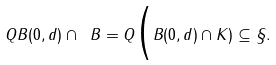Convert formula to latex. <formula><loc_0><loc_0><loc_500><loc_500>Q B ( 0 , d ) \cap \ B = Q \Big ( B ( 0 , d ) \cap K ) \subseteq { \S } .</formula> 